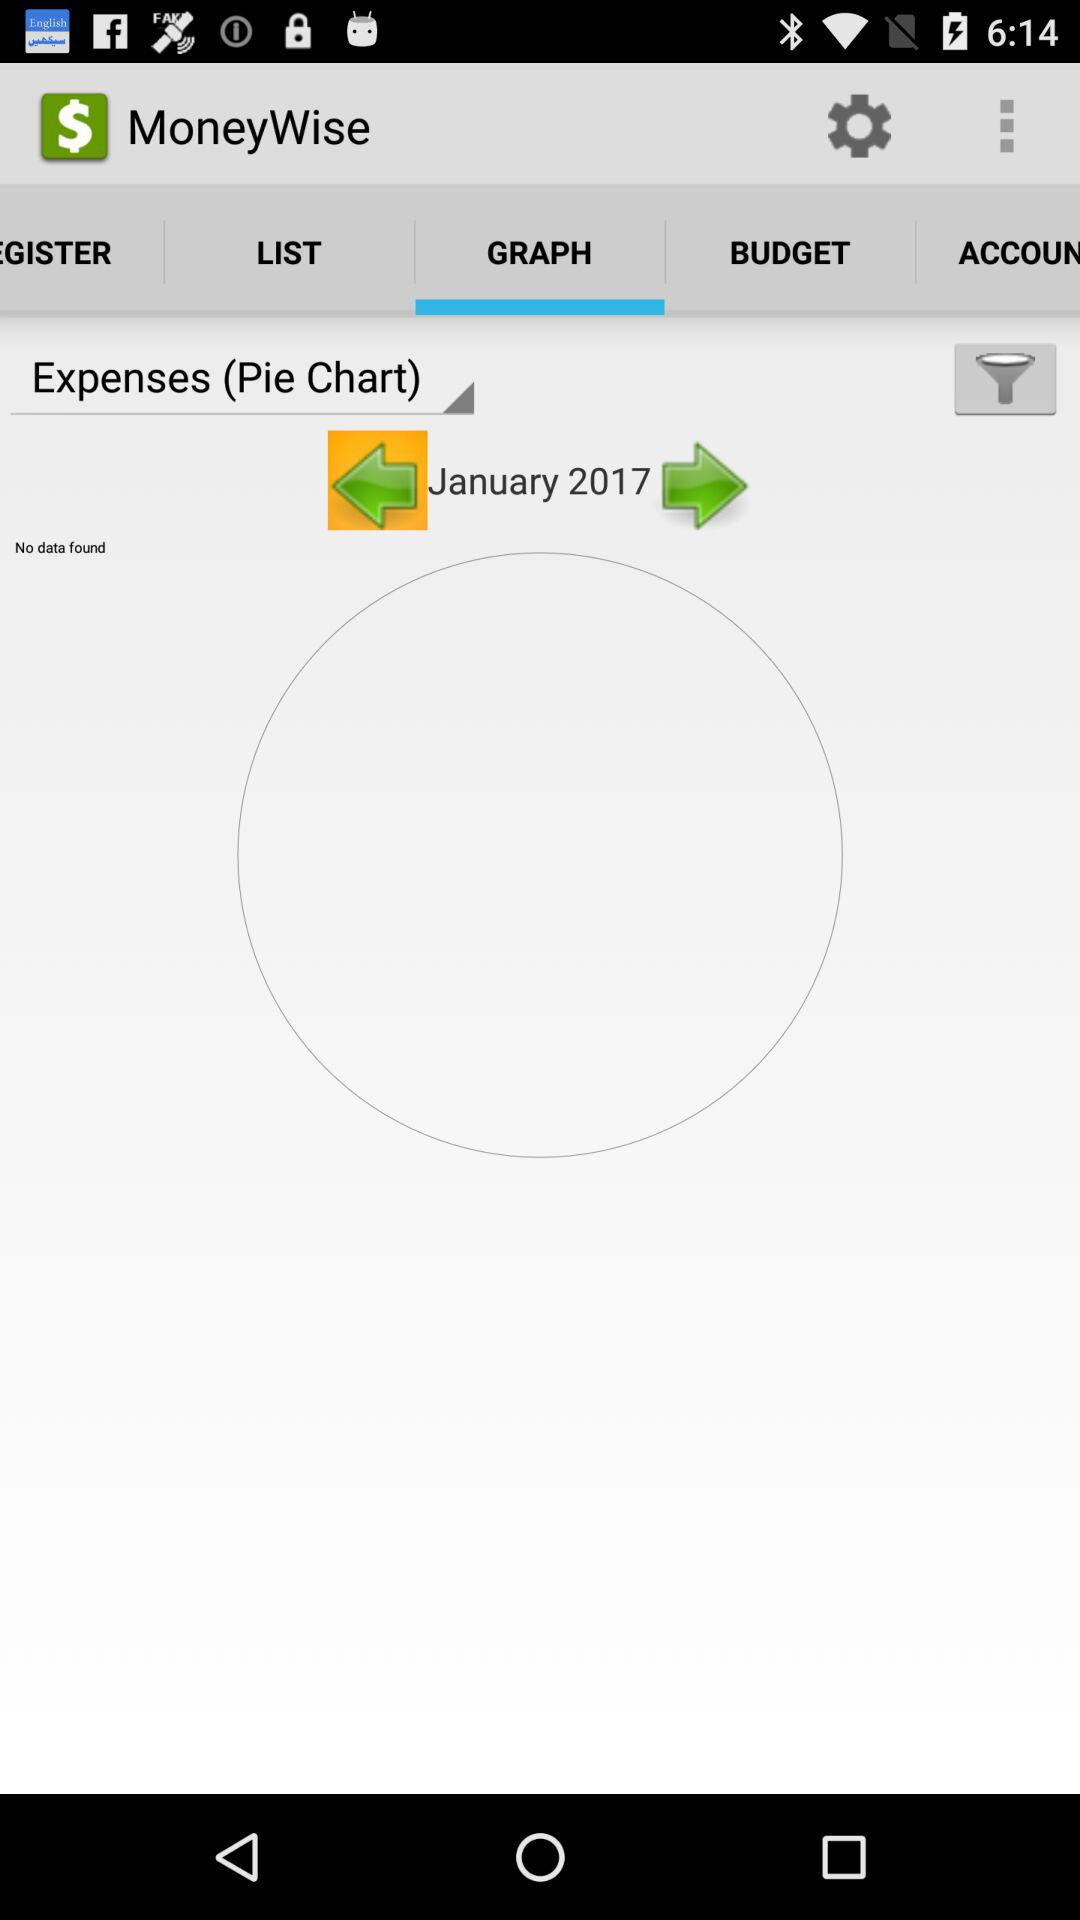What is the selected year? The selected year is 2017. 